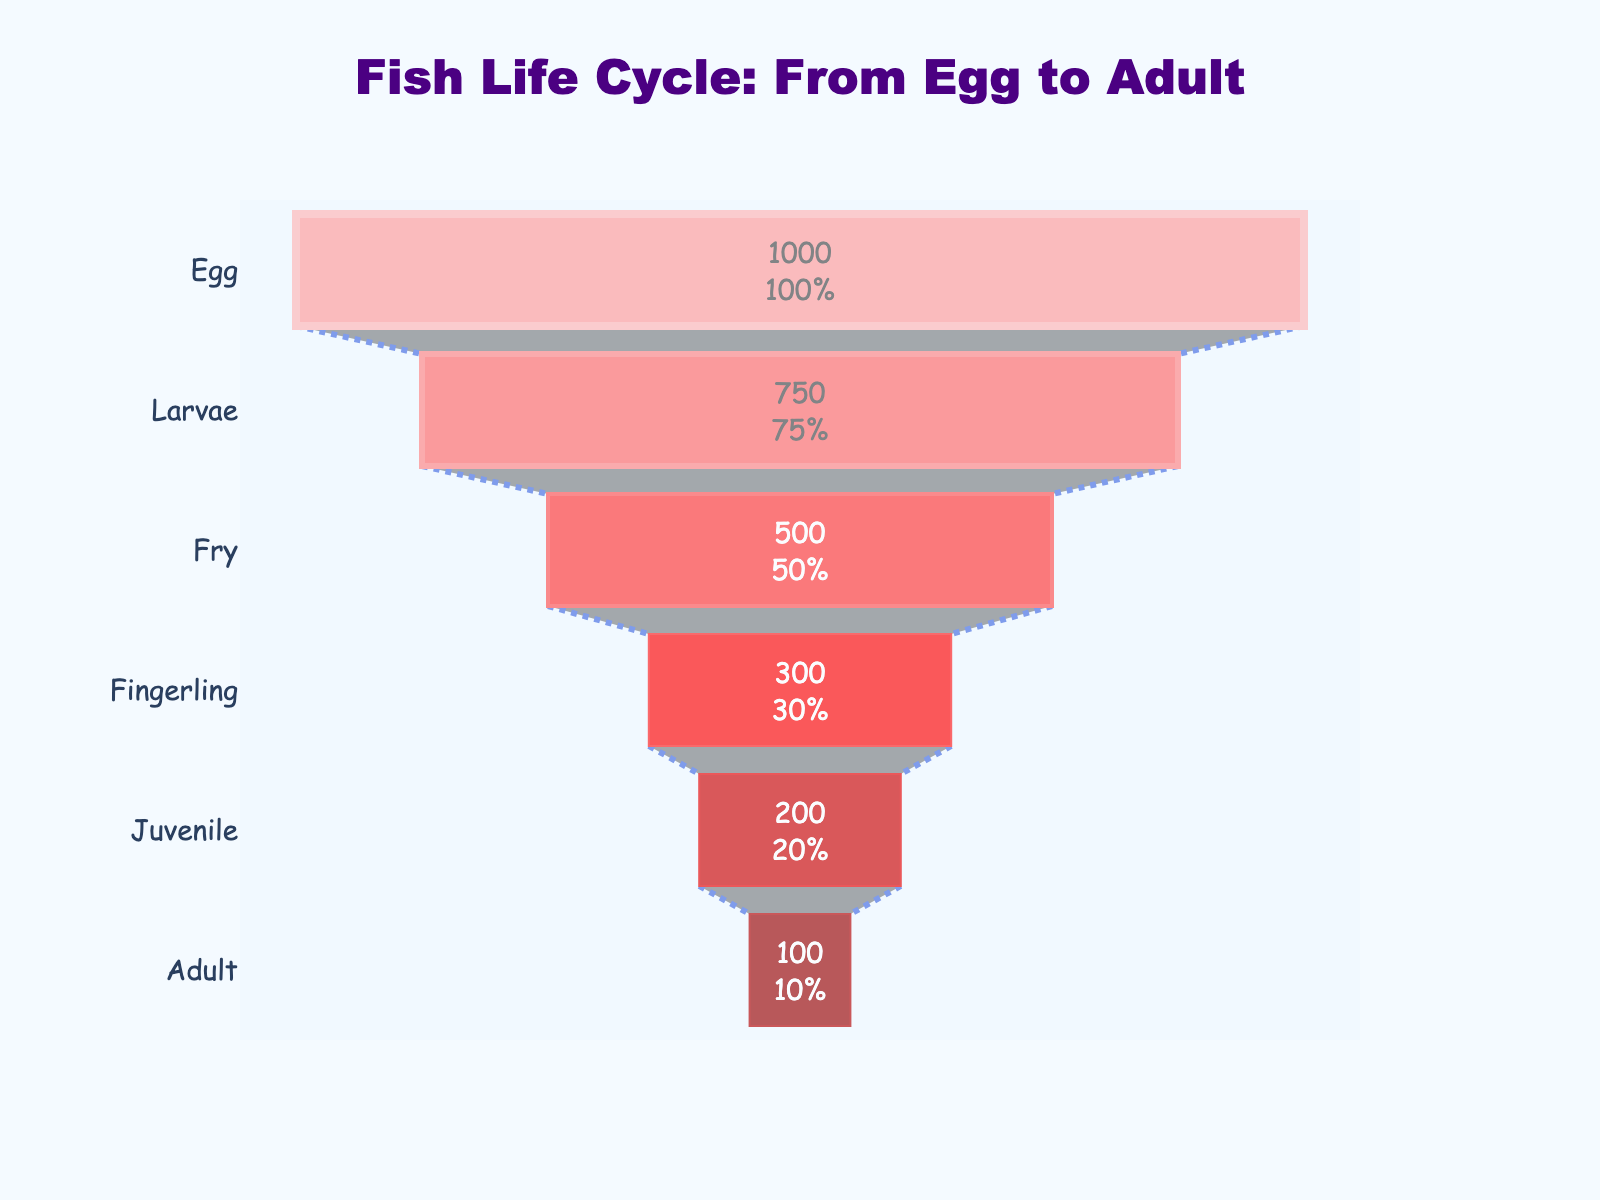What's the title of the funnel chart? The title is located at the top of the chart in a larger font. It should provide an overview of what the chart is about. The title reads "Fish Life Cycle: From Egg to Adult".
Answer: Fish Life Cycle: From Egg to Adult How many stages are shown on the funnel chart? The stages are represented by different sections of the funnel, each labeled with a stage of the fish life cycle. There are six stages listed from top to bottom.
Answer: 6 What stage has the highest number of fish? The numbers of fish decrease as you move down the funnel. The top stage, "Egg", has the highest number, with 1,000 fish.
Answer: Egg What percentage of the initial fish remain at the "Larvae" stage? Next to each section's number is a percentage value showing the proportion of fish remaining from the initial 1,000. For "Larvae", it shows the remaining number is 750 which is 75% of the initial 1,000.
Answer: 75% Between which two stages is the largest drop in fish numbers? To determine the largest drop, compare the differences between successive stages. "Fry" to "Fingerling" sees a decrease from 500 to 300, which is 200 fish, the largest drop.
Answer: Fry to Fingerling How many fish reach the adult stage? The Adult stage is the lowest section in the funnel. The number inside it shows there are 100 fish.
Answer: 100 Which color is used to represent the "Juvenile" stage? Different sections are colored uniquely. "Juvenile" is the second to last section, colored dark red.
Answer: Dark red By what percentage do the fish numbers decrease from "Fingerling" to "Juvenile"? Calculate the percentage decrease by subtracting Juvenile (200) from Fingerling (300), giving 100. Then divide 100 by the initial value of 300, and multiply by 100. The percentage decrease is 33.33%.
Answer: 33.33% Which stages have fewer than 500 fish? Look at the sections with numbers less than 500. The stages "Fingerling", "Juvenile", and "Adult" all have fewer than 500 fish.
Answer: Fingerling, Juvenile, Adult What's the color scheme used in the chart? Colors gradually darken from lighter red at the top to darker red at the bottom. The top stages (Egg, Larvae) are lighter, while the lower stages (Juvenile, Adult) are darker.
Answer: Light red to dark red How many different widths are used for the section outlines? The outline widths decrease downward, and are visibly different in "Egg", "Larvae", "Fry", and "Fingerling". The width is the same for the final three stages. There are 4 distinct widths.
Answer: 4 